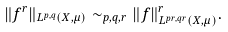<formula> <loc_0><loc_0><loc_500><loc_500>\| f ^ { r } \| _ { L ^ { p , q } ( X , \mu ) } \sim _ { p , q , r } \| f \| _ { L ^ { p r , q r } ( X , \mu ) } ^ { r } .</formula> 